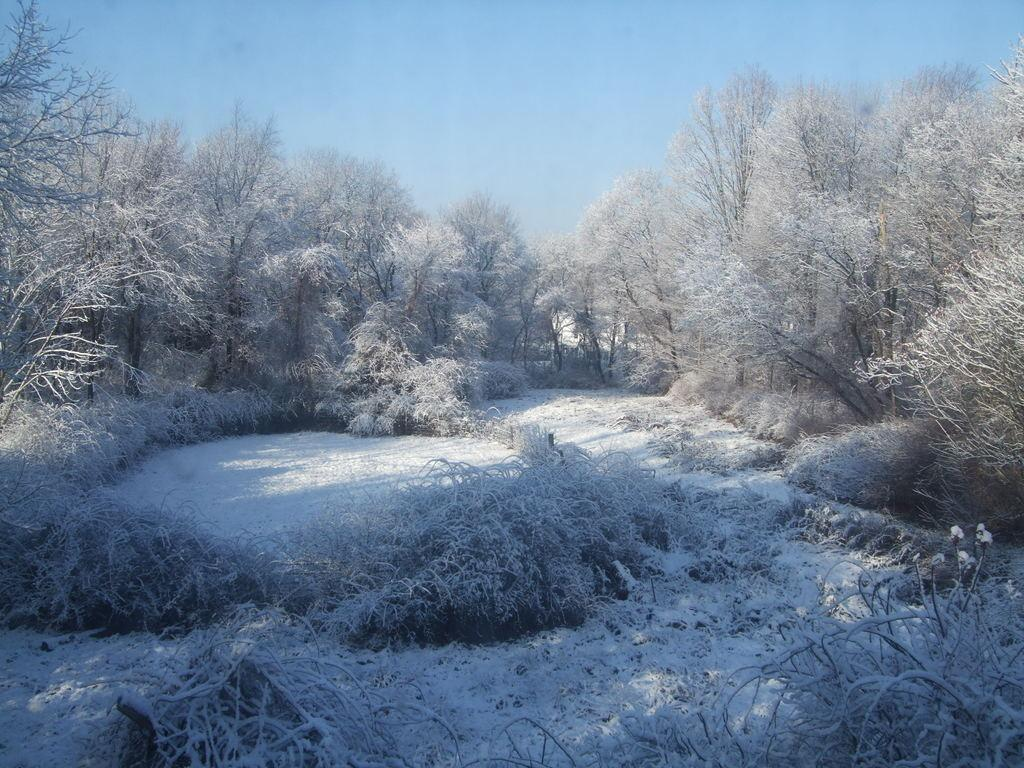What type of vegetation is present in the image? There are many trees and shrubs on the ground in the image. How is the ground covered in the image? There is snow all over the place in the image. What is the condition of the sky in the image? The sky is clear in the image. What type of answer can be seen written on the trees in the image? There are no answers written on the trees in the image; it features trees, shrubs, snow, and a clear sky. How many pigs are visible in the image? There are no pigs present in the image. 